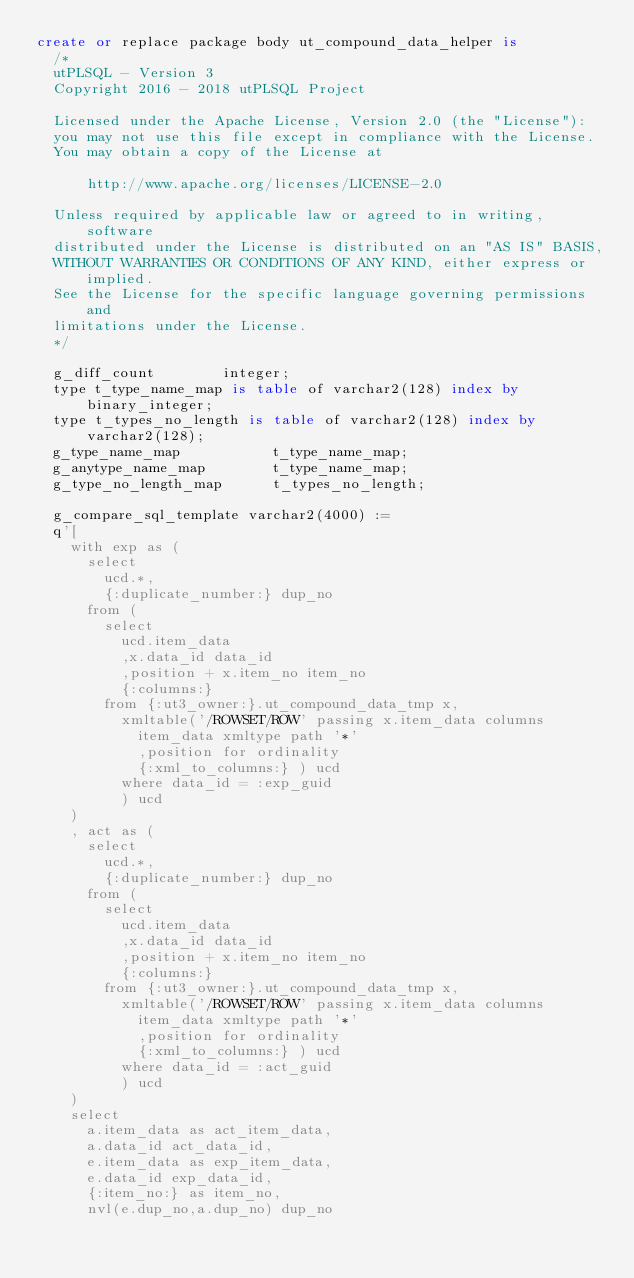Convert code to text. <code><loc_0><loc_0><loc_500><loc_500><_SQL_>create or replace package body ut_compound_data_helper is
  /*
  utPLSQL - Version 3
  Copyright 2016 - 2018 utPLSQL Project

  Licensed under the Apache License, Version 2.0 (the "License"):
  you may not use this file except in compliance with the License.
  You may obtain a copy of the License at

      http://www.apache.org/licenses/LICENSE-2.0

  Unless required by applicable law or agreed to in writing, software
  distributed under the License is distributed on an "AS IS" BASIS,
  WITHOUT WARRANTIES OR CONDITIONS OF ANY KIND, either express or implied.
  See the License for the specific language governing permissions and
  limitations under the License.
  */

  g_diff_count        integer;
  type t_type_name_map is table of varchar2(128) index by binary_integer;
  type t_types_no_length is table of varchar2(128) index by varchar2(128);
  g_type_name_map           t_type_name_map;
  g_anytype_name_map        t_type_name_map;
  g_type_no_length_map      t_types_no_length;

  g_compare_sql_template varchar2(4000) :=
  q'[
    with exp as (
      select 
        ucd.*, 
        {:duplicate_number:} dup_no
      from (
        select 
          ucd.item_data
          ,x.data_id data_id 
          ,position + x.item_no item_no
          {:columns:}
        from {:ut3_owner:}.ut_compound_data_tmp x,
          xmltable('/ROWSET/ROW' passing x.item_data columns
            item_data xmltype path '*'
            ,position for ordinality
            {:xml_to_columns:} ) ucd
          where data_id = :exp_guid
          ) ucd
    )
    , act as (
      select 
        ucd.*,
        {:duplicate_number:} dup_no
      from (
        select 
          ucd.item_data
          ,x.data_id data_id
          ,position + x.item_no item_no 
          {:columns:}
        from {:ut3_owner:}.ut_compound_data_tmp x,
          xmltable('/ROWSET/ROW' passing x.item_data columns 
            item_data xmltype path '*'
            ,position for ordinality
            {:xml_to_columns:} ) ucd
          where data_id = :act_guid
          ) ucd
    )   
    select 
      a.item_data as act_item_data, 
      a.data_id act_data_id,
      e.item_data as exp_item_data, 
      e.data_id exp_data_id,
      {:item_no:} as item_no, 
      nvl(e.dup_no,a.dup_no) dup_no </code> 